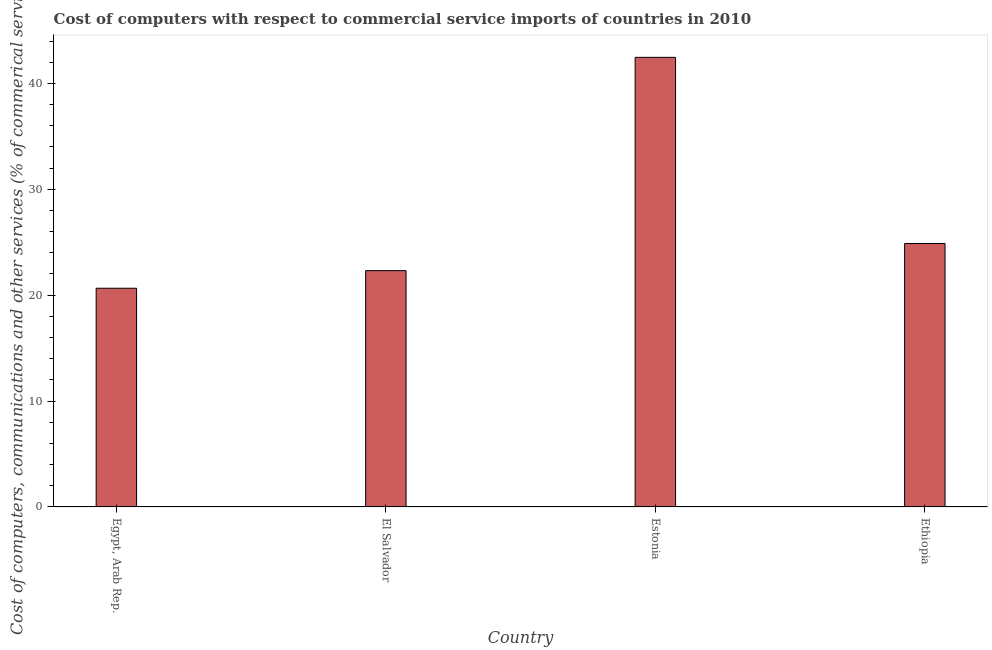What is the title of the graph?
Your answer should be compact. Cost of computers with respect to commercial service imports of countries in 2010. What is the label or title of the Y-axis?
Offer a very short reply. Cost of computers, communications and other services (% of commerical service exports). What is the  computer and other services in Ethiopia?
Your response must be concise. 24.88. Across all countries, what is the maximum cost of communications?
Provide a succinct answer. 42.46. Across all countries, what is the minimum cost of communications?
Ensure brevity in your answer.  20.65. In which country was the cost of communications maximum?
Your response must be concise. Estonia. In which country was the  computer and other services minimum?
Your answer should be very brief. Egypt, Arab Rep. What is the sum of the cost of communications?
Your response must be concise. 110.31. What is the difference between the  computer and other services in Egypt, Arab Rep. and Ethiopia?
Ensure brevity in your answer.  -4.23. What is the average  computer and other services per country?
Your answer should be very brief. 27.58. What is the median cost of communications?
Your response must be concise. 23.6. What is the ratio of the cost of communications in Egypt, Arab Rep. to that in Ethiopia?
Your answer should be compact. 0.83. Is the cost of communications in El Salvador less than that in Ethiopia?
Your response must be concise. Yes. What is the difference between the highest and the second highest  computer and other services?
Your answer should be very brief. 17.58. What is the difference between the highest and the lowest cost of communications?
Your response must be concise. 21.81. In how many countries, is the  computer and other services greater than the average  computer and other services taken over all countries?
Your answer should be compact. 1. How many bars are there?
Offer a very short reply. 4. Are the values on the major ticks of Y-axis written in scientific E-notation?
Your answer should be very brief. No. What is the Cost of computers, communications and other services (% of commerical service exports) in Egypt, Arab Rep.?
Provide a short and direct response. 20.65. What is the Cost of computers, communications and other services (% of commerical service exports) in El Salvador?
Your answer should be very brief. 22.32. What is the Cost of computers, communications and other services (% of commerical service exports) of Estonia?
Ensure brevity in your answer.  42.46. What is the Cost of computers, communications and other services (% of commerical service exports) of Ethiopia?
Your answer should be compact. 24.88. What is the difference between the Cost of computers, communications and other services (% of commerical service exports) in Egypt, Arab Rep. and El Salvador?
Your response must be concise. -1.66. What is the difference between the Cost of computers, communications and other services (% of commerical service exports) in Egypt, Arab Rep. and Estonia?
Offer a very short reply. -21.81. What is the difference between the Cost of computers, communications and other services (% of commerical service exports) in Egypt, Arab Rep. and Ethiopia?
Make the answer very short. -4.23. What is the difference between the Cost of computers, communications and other services (% of commerical service exports) in El Salvador and Estonia?
Offer a terse response. -20.14. What is the difference between the Cost of computers, communications and other services (% of commerical service exports) in El Salvador and Ethiopia?
Offer a terse response. -2.56. What is the difference between the Cost of computers, communications and other services (% of commerical service exports) in Estonia and Ethiopia?
Offer a very short reply. 17.58. What is the ratio of the Cost of computers, communications and other services (% of commerical service exports) in Egypt, Arab Rep. to that in El Salvador?
Your answer should be compact. 0.93. What is the ratio of the Cost of computers, communications and other services (% of commerical service exports) in Egypt, Arab Rep. to that in Estonia?
Give a very brief answer. 0.49. What is the ratio of the Cost of computers, communications and other services (% of commerical service exports) in Egypt, Arab Rep. to that in Ethiopia?
Provide a short and direct response. 0.83. What is the ratio of the Cost of computers, communications and other services (% of commerical service exports) in El Salvador to that in Estonia?
Keep it short and to the point. 0.53. What is the ratio of the Cost of computers, communications and other services (% of commerical service exports) in El Salvador to that in Ethiopia?
Your answer should be very brief. 0.9. What is the ratio of the Cost of computers, communications and other services (% of commerical service exports) in Estonia to that in Ethiopia?
Your answer should be compact. 1.71. 